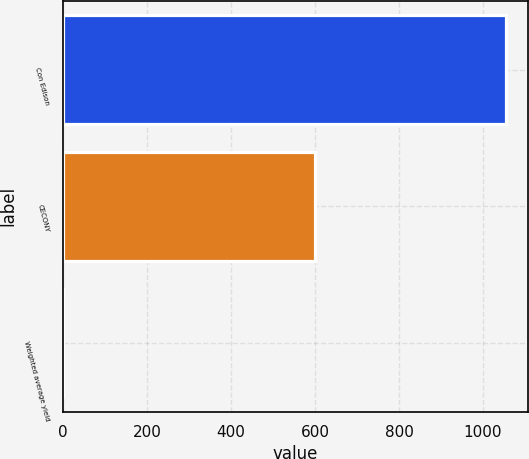Convert chart to OTSL. <chart><loc_0><loc_0><loc_500><loc_500><bar_chart><fcel>Con Edison<fcel>CECONY<fcel>Weighted average yield<nl><fcel>1054<fcel>600<fcel>1<nl></chart> 